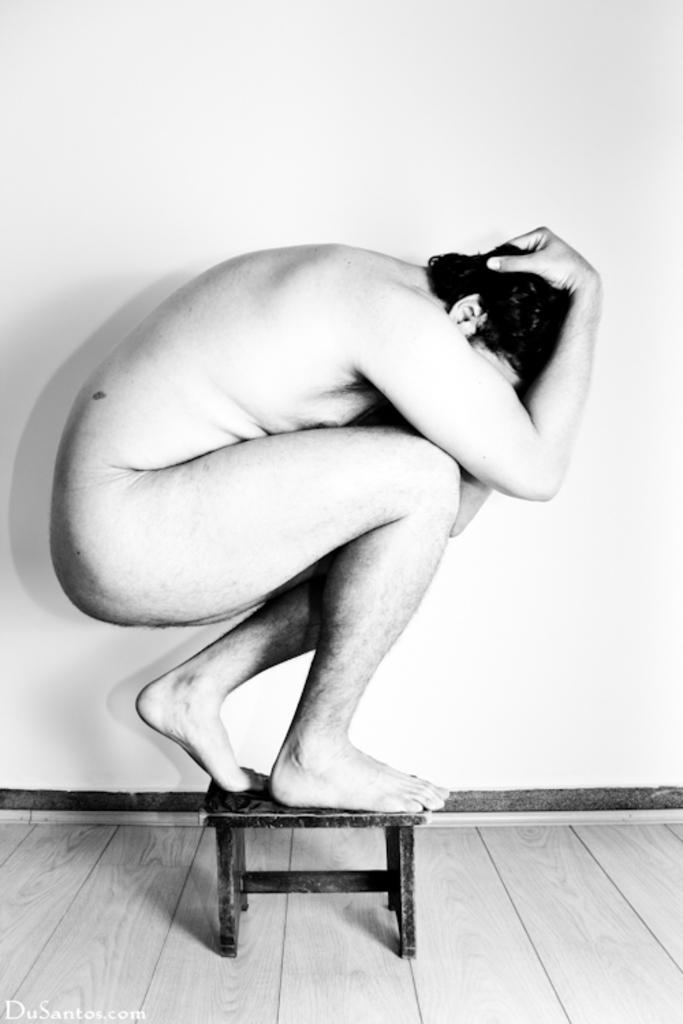What is the main subject of the image? There is a naked man in the image. What is the man doing in the image? The man is sitting on a small table and is in a squat position. What is the color of the background in the image? The background in the image is white. What type of servant is attending to the man in the image? There is no servant present in the image. What kind of destruction is happening in the image? There is no destruction depicted in the image. 